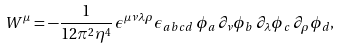<formula> <loc_0><loc_0><loc_500><loc_500>W ^ { \mu } = - \frac { 1 } { 1 2 \pi ^ { 2 } \eta ^ { 4 } } \, \epsilon ^ { \mu \nu \lambda \rho } \epsilon _ { a b c d } \, \phi _ { a } \, \partial _ { \nu } \phi _ { b } \, \partial _ { \lambda } \phi _ { c } \, \partial _ { \rho } \phi _ { d } ,</formula> 